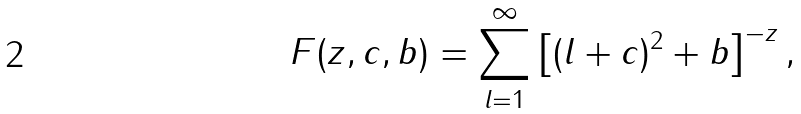Convert formula to latex. <formula><loc_0><loc_0><loc_500><loc_500>F ( z , c , b ) = \sum _ { l = 1 } ^ { \infty } \left [ ( l + c ) ^ { 2 } + b \right ] ^ { - z } ,</formula> 